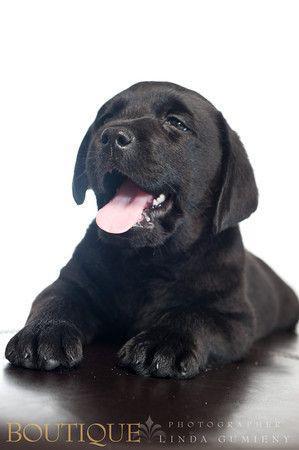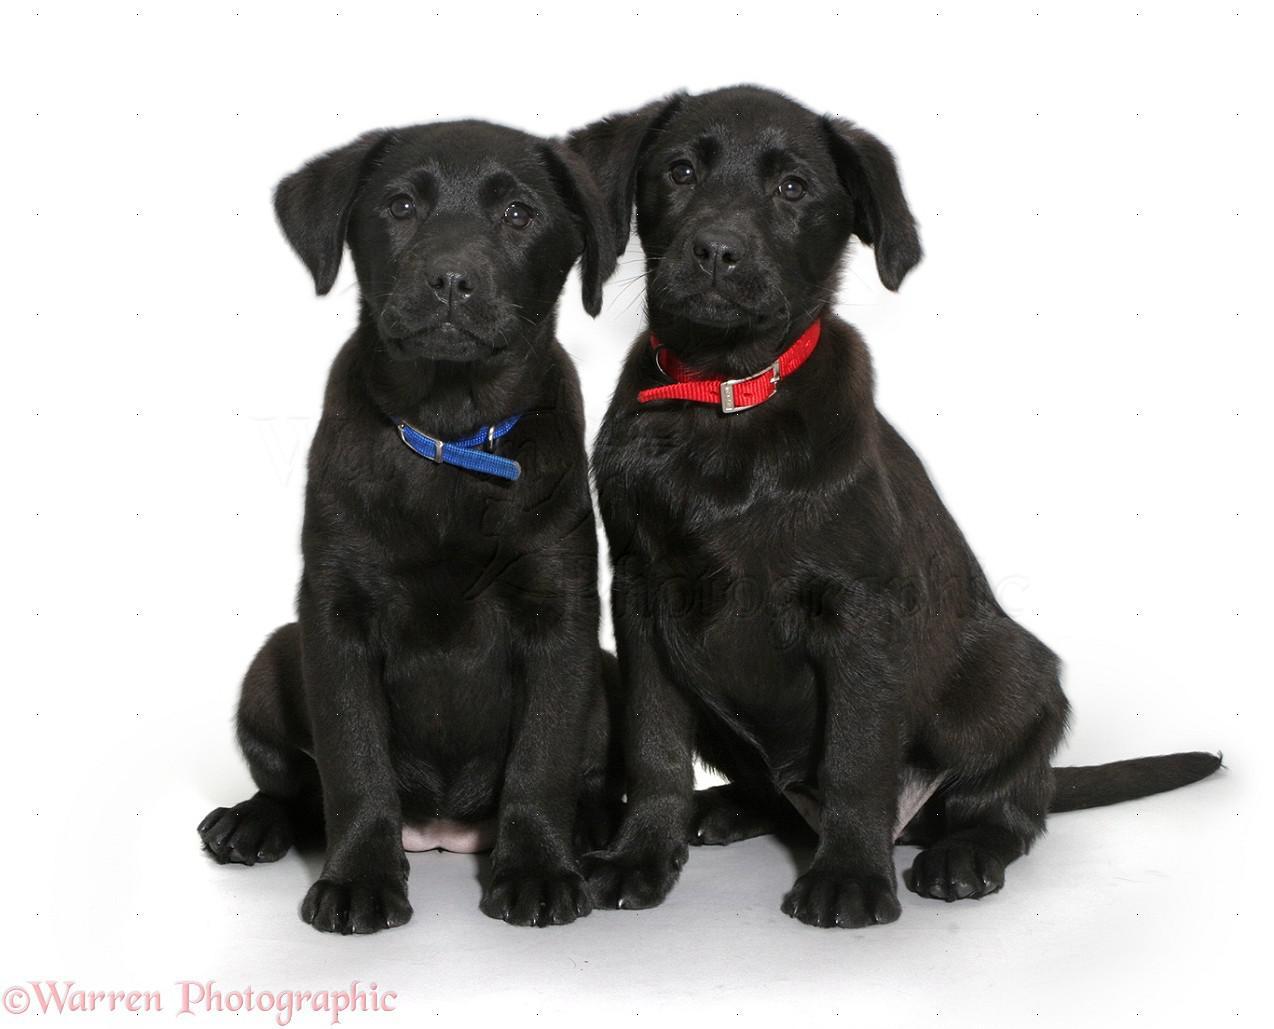The first image is the image on the left, the second image is the image on the right. Evaluate the accuracy of this statement regarding the images: "One image shows a single black dog and the other shows a pair of brown dogs.". Is it true? Answer yes or no. No. The first image is the image on the left, the second image is the image on the right. For the images shown, is this caption "At least one dog has its tongue out." true? Answer yes or no. Yes. 